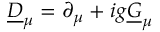Convert formula to latex. <formula><loc_0><loc_0><loc_500><loc_500>\underline { D } _ { \mu } = \partial _ { \mu } + i g \underline { G } _ { \mu }</formula> 